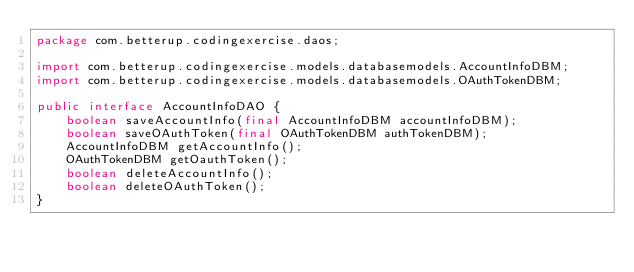Convert code to text. <code><loc_0><loc_0><loc_500><loc_500><_Java_>package com.betterup.codingexercise.daos;

import com.betterup.codingexercise.models.databasemodels.AccountInfoDBM;
import com.betterup.codingexercise.models.databasemodels.OAuthTokenDBM;

public interface AccountInfoDAO {
    boolean saveAccountInfo(final AccountInfoDBM accountInfoDBM);
    boolean saveOAuthToken(final OAuthTokenDBM authTokenDBM);
    AccountInfoDBM getAccountInfo();
    OAuthTokenDBM getOauthToken();
    boolean deleteAccountInfo();
    boolean deleteOAuthToken();
}
</code> 